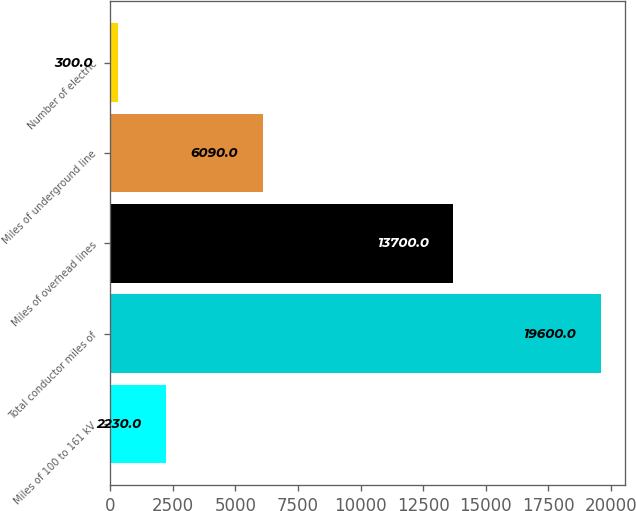<chart> <loc_0><loc_0><loc_500><loc_500><bar_chart><fcel>Miles of 100 to 161 kV<fcel>Total conductor miles of<fcel>Miles of overhead lines<fcel>Miles of underground line<fcel>Number of electric<nl><fcel>2230<fcel>19600<fcel>13700<fcel>6090<fcel>300<nl></chart> 